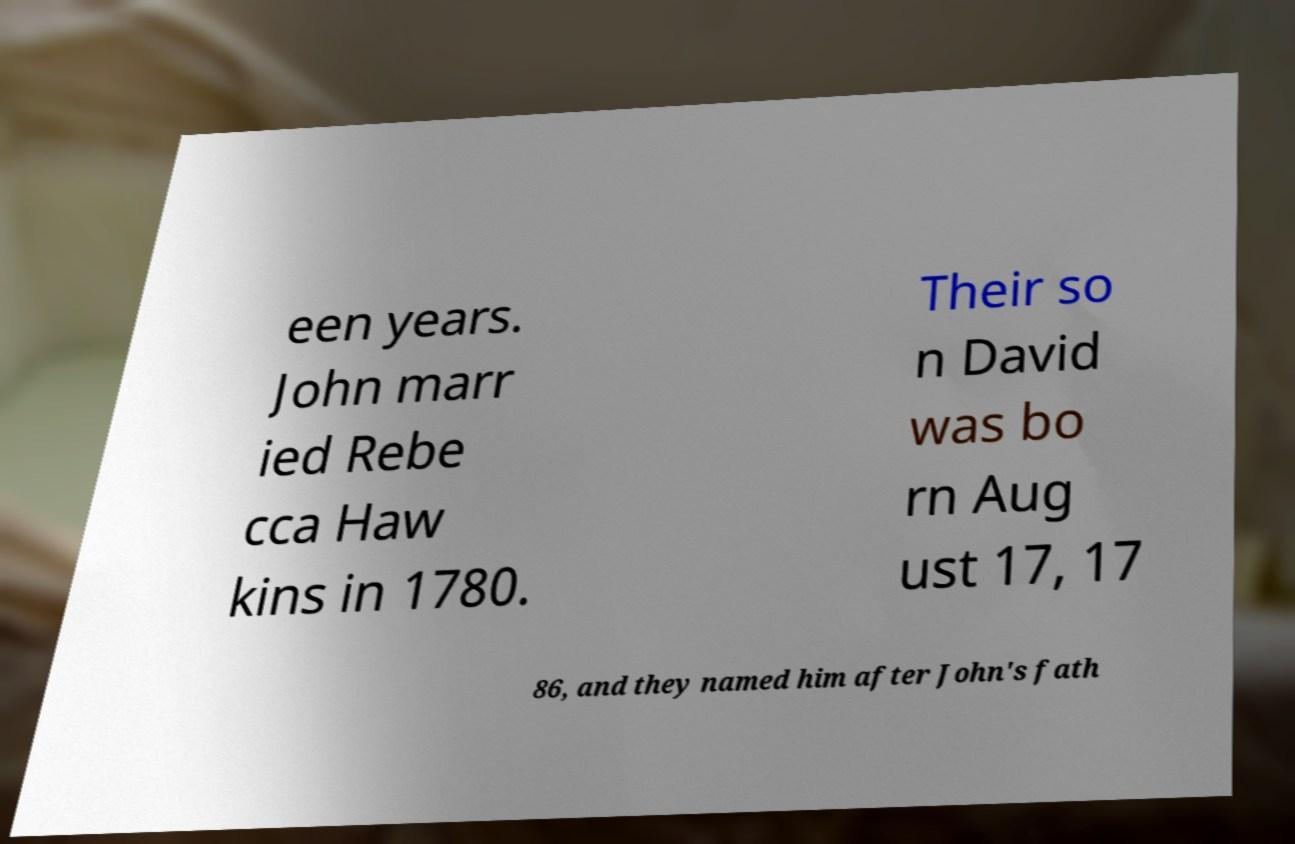Please read and relay the text visible in this image. What does it say? een years. John marr ied Rebe cca Haw kins in 1780. Their so n David was bo rn Aug ust 17, 17 86, and they named him after John's fath 